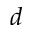<formula> <loc_0><loc_0><loc_500><loc_500>d</formula> 